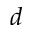<formula> <loc_0><loc_0><loc_500><loc_500>d</formula> 